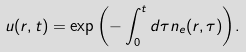<formula> <loc_0><loc_0><loc_500><loc_500>u ( { r } , t ) = \exp { \left ( - \int _ { 0 } ^ { t } d \tau n _ { e } ( { r } , \tau ) \right ) } .</formula> 